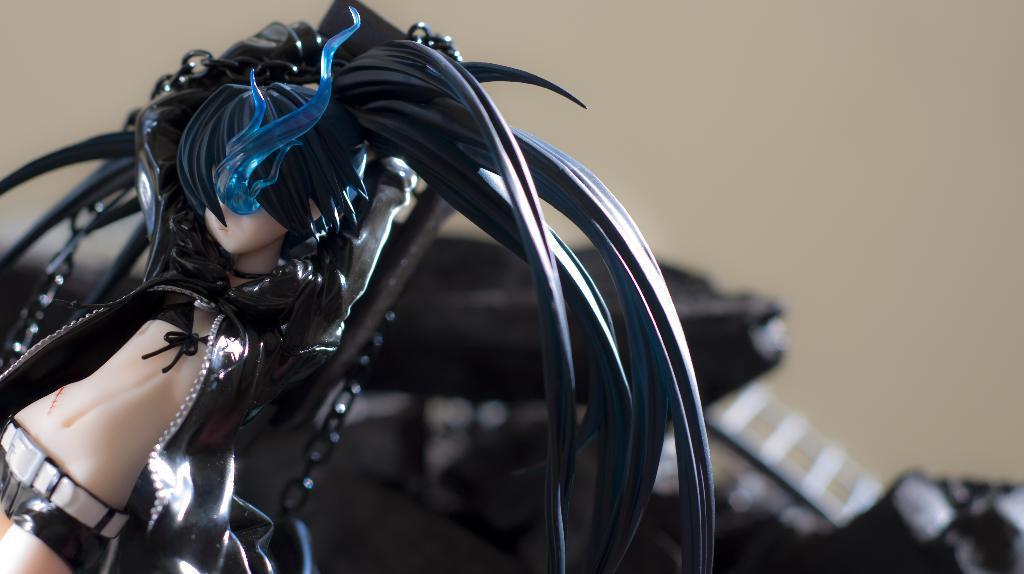Describe this image in one or two sentences. In this image I can see a toy which is cream, black, white and blue in color. In the background I can see few objects which are black in color and the cream colored wall. 